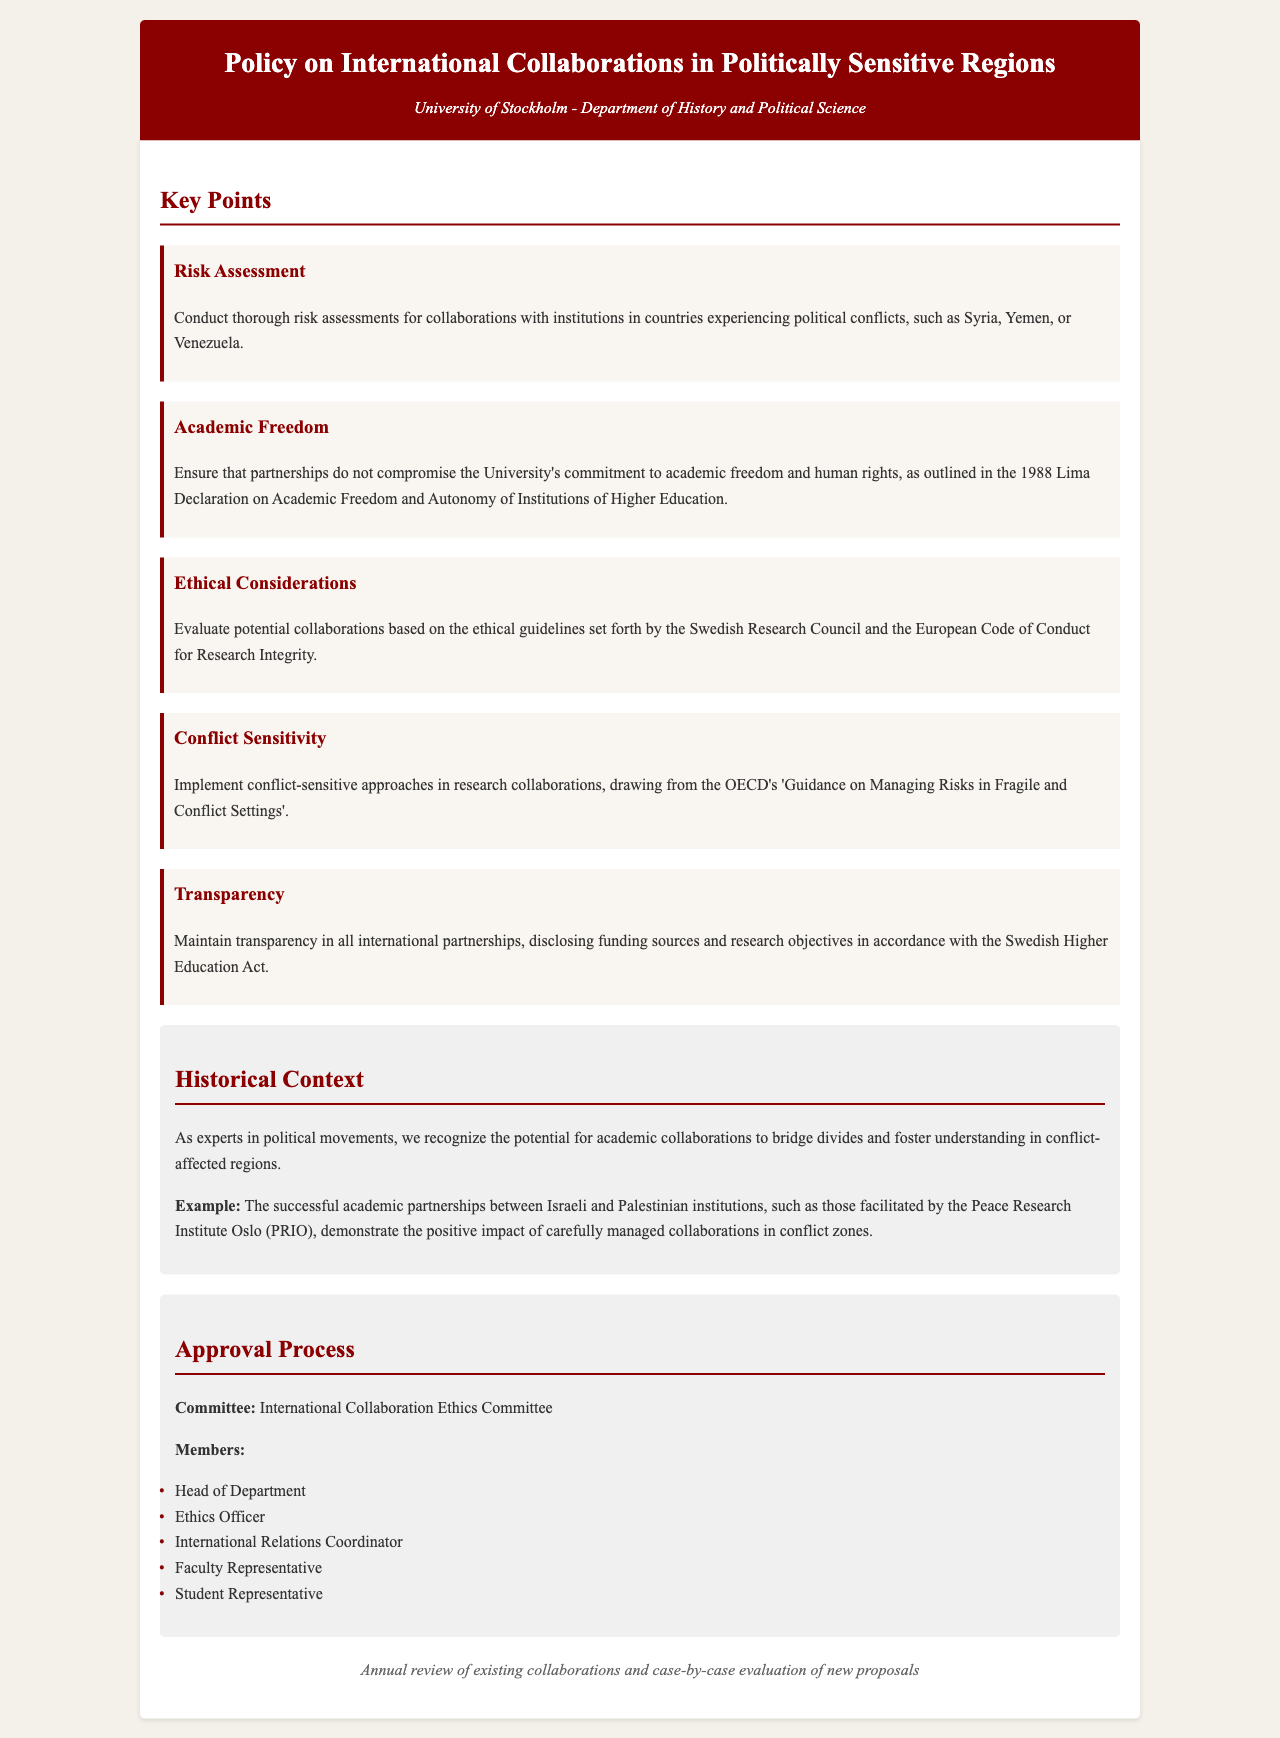What is the title of the document? The title is a key element that provides the main subject of the content in the document.
Answer: Policy on International Collaborations in Politically Sensitive Regions Who is responsible for conducting risk assessments? This information can typically be found in sections discussing responsibilities within the policy document.
Answer: Collaborations with institutions in countries experiencing political conflicts What are the ethical guidelines referenced in the document? The document references specific ethical guidelines that are important for ensuring proper conduct in collaborations.
Answer: Swedish Research Council and the European Code of Conduct for Research Integrity Which committee reviews the collaborations? This refers to the body designated for oversight and approval of international collaborations as stated in the document.
Answer: International Collaboration Ethics Committee What is the purpose of maintaining transparency in partnerships? Transparency is a principle often emphasized in policy documents to ensure ethical practices.
Answer: Disclosing funding sources and research objectives How often is the policy reviewed? The review period is a critical component of policy documents that indicates the frequency of evaluation.
Answer: Annual review of existing collaborations and case-by-case evaluation of new proposals What example is provided to demonstrate successful collaboration? The document may include historical examples to illustrate the effectiveness of the policies in practice.
Answer: Partnerships between Israeli and Palestinian institutions What is emphasized as a critical consideration in research collaborations? This is often highlighted in policy documents to underline the importance of thoughtful approaches to sensitive situations.
Answer: Conflict-sensitive approaches 